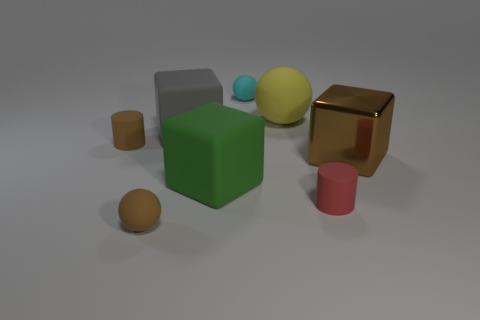What could be the purpose of showing these objects together? These objects could have been arranged together for several purposes. This could be a rendering to demonstrate lighting and shading in computer graphics. It might also be used as a part of a cognitive test to assess visual perception, or as an example in an educational setting to teach about geometry and color theory. Lastly, it could purely be a work of digital art, arranged for aesthetic pleasure and the exploration of simple forms and colors. 